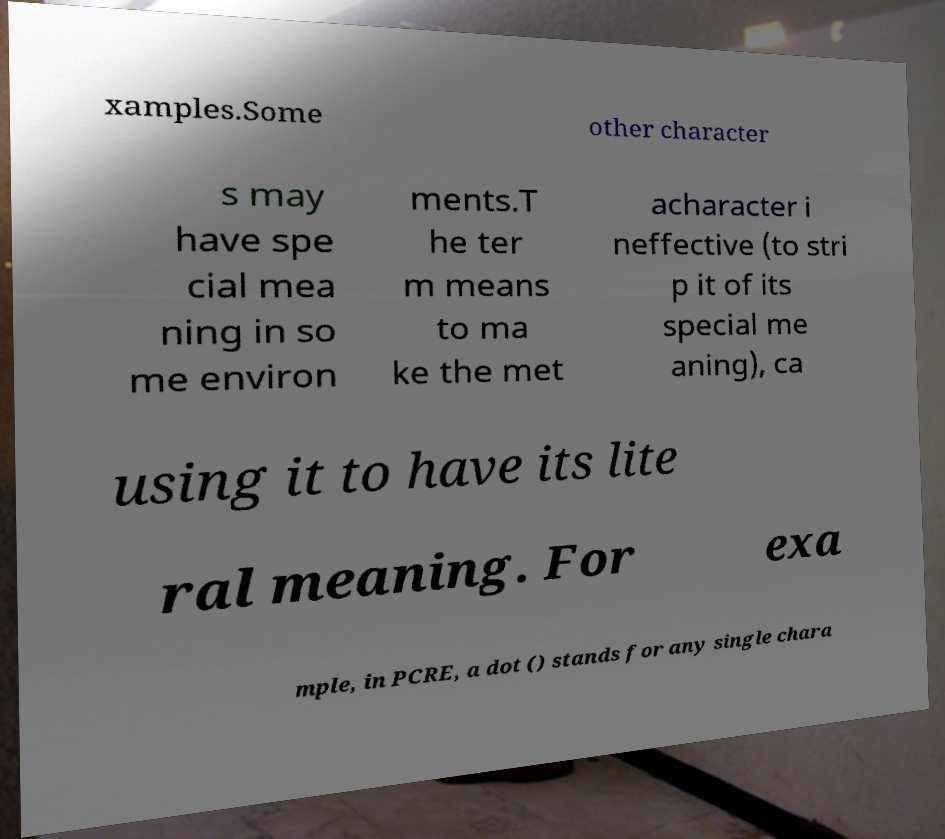Can you accurately transcribe the text from the provided image for me? xamples.Some other character s may have spe cial mea ning in so me environ ments.T he ter m means to ma ke the met acharacter i neffective (to stri p it of its special me aning), ca using it to have its lite ral meaning. For exa mple, in PCRE, a dot () stands for any single chara 